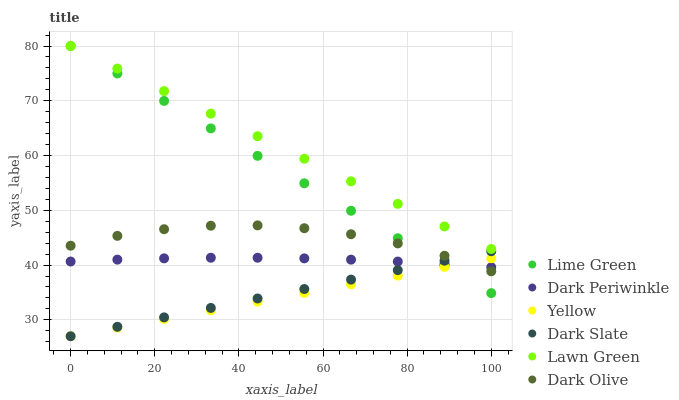Does Yellow have the minimum area under the curve?
Answer yes or no. Yes. Does Lawn Green have the maximum area under the curve?
Answer yes or no. Yes. Does Dark Olive have the minimum area under the curve?
Answer yes or no. No. Does Dark Olive have the maximum area under the curve?
Answer yes or no. No. Is Yellow the smoothest?
Answer yes or no. Yes. Is Dark Olive the roughest?
Answer yes or no. Yes. Is Dark Olive the smoothest?
Answer yes or no. No. Is Yellow the roughest?
Answer yes or no. No. Does Yellow have the lowest value?
Answer yes or no. Yes. Does Dark Olive have the lowest value?
Answer yes or no. No. Does Lime Green have the highest value?
Answer yes or no. Yes. Does Dark Olive have the highest value?
Answer yes or no. No. Is Dark Periwinkle less than Lawn Green?
Answer yes or no. Yes. Is Lawn Green greater than Yellow?
Answer yes or no. Yes. Does Dark Olive intersect Dark Periwinkle?
Answer yes or no. Yes. Is Dark Olive less than Dark Periwinkle?
Answer yes or no. No. Is Dark Olive greater than Dark Periwinkle?
Answer yes or no. No. Does Dark Periwinkle intersect Lawn Green?
Answer yes or no. No. 